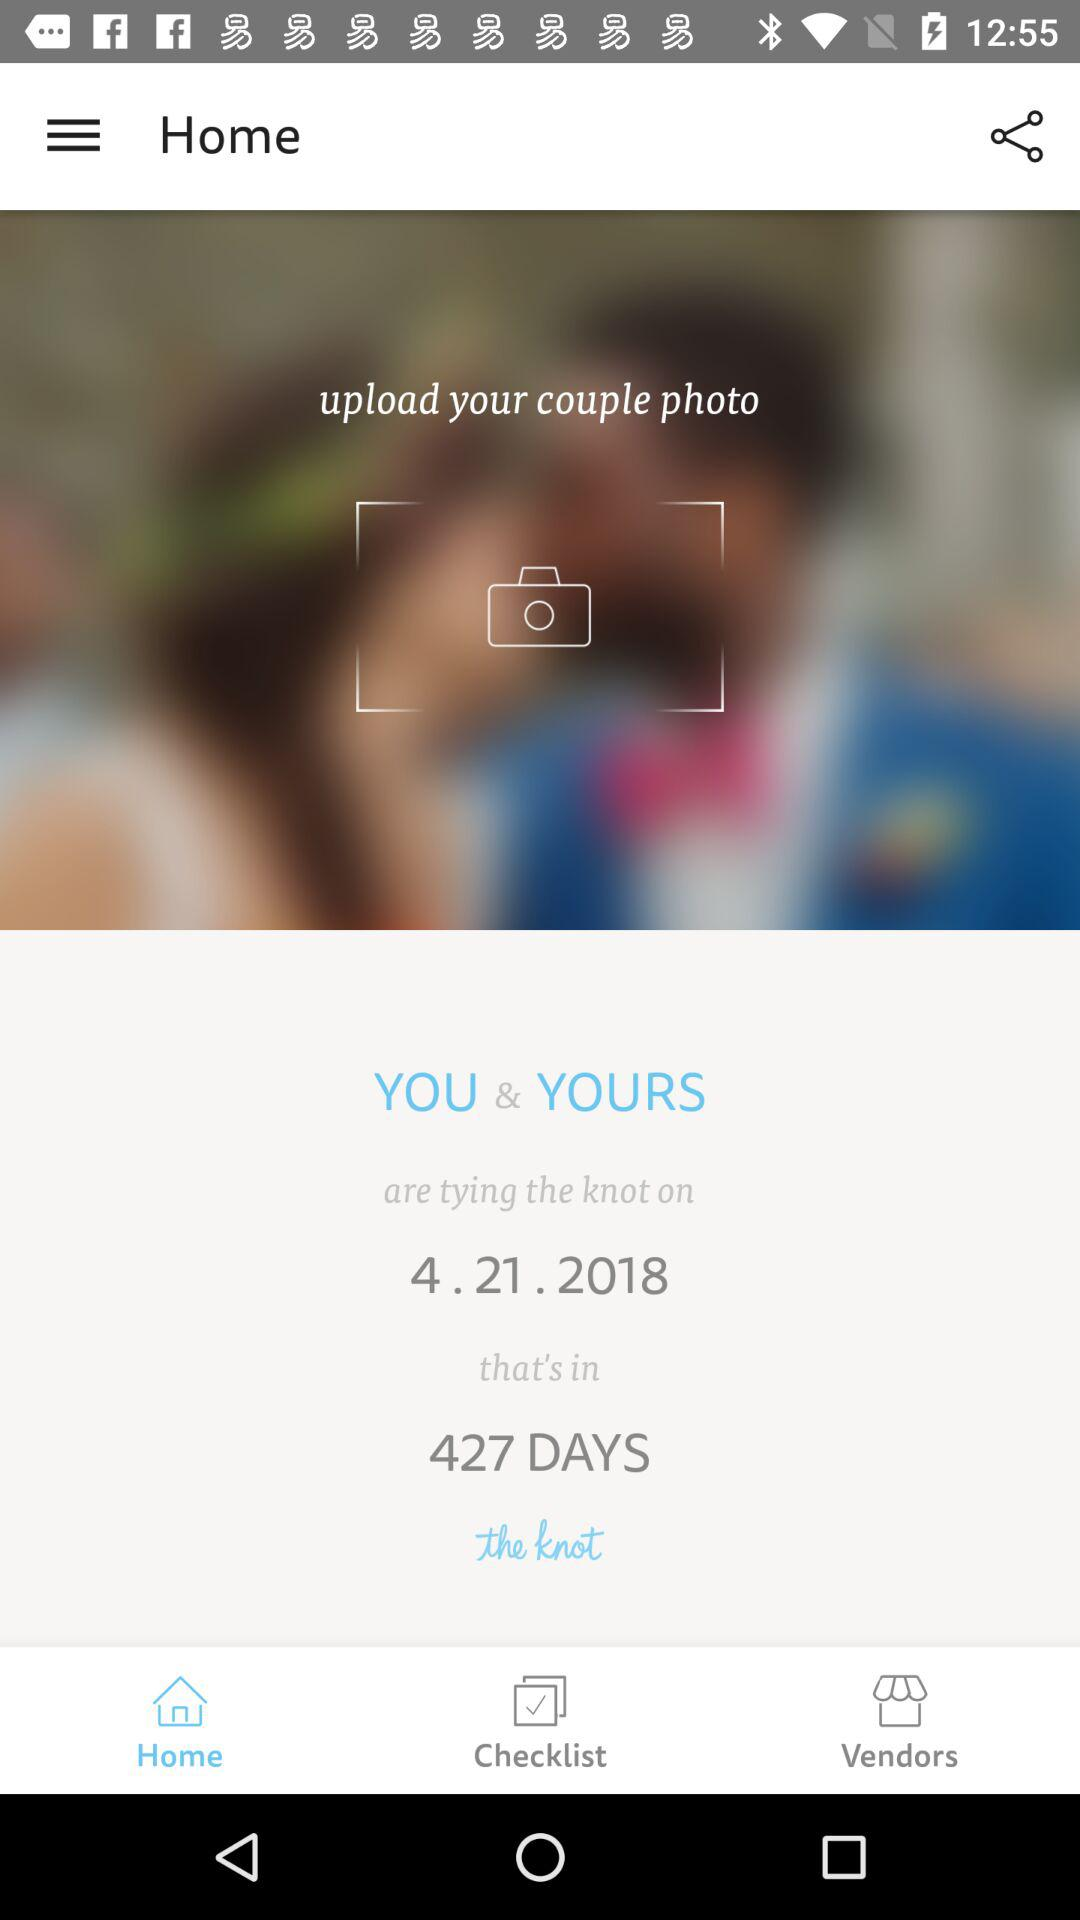What is the count of days? The count of days is 427. 